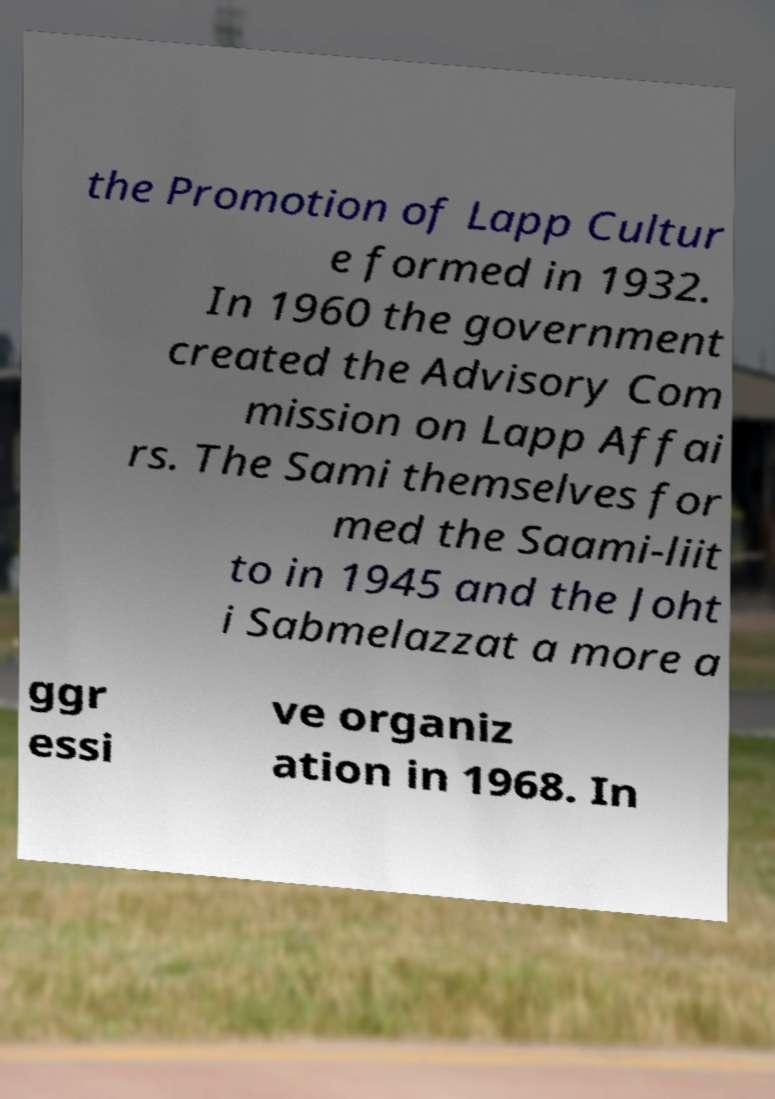Could you assist in decoding the text presented in this image and type it out clearly? the Promotion of Lapp Cultur e formed in 1932. In 1960 the government created the Advisory Com mission on Lapp Affai rs. The Sami themselves for med the Saami-liit to in 1945 and the Joht i Sabmelazzat a more a ggr essi ve organiz ation in 1968. In 